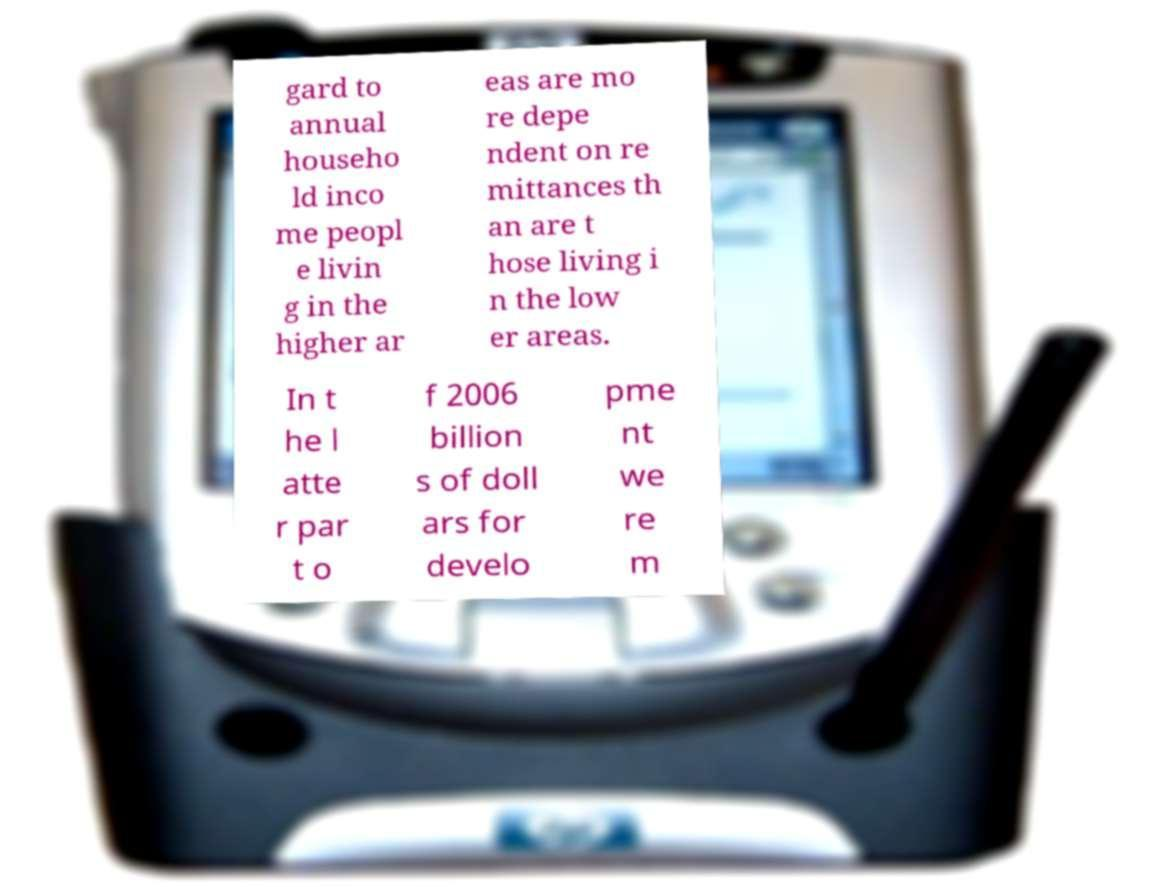For documentation purposes, I need the text within this image transcribed. Could you provide that? gard to annual househo ld inco me peopl e livin g in the higher ar eas are mo re depe ndent on re mittances th an are t hose living i n the low er areas. In t he l atte r par t o f 2006 billion s of doll ars for develo pme nt we re m 